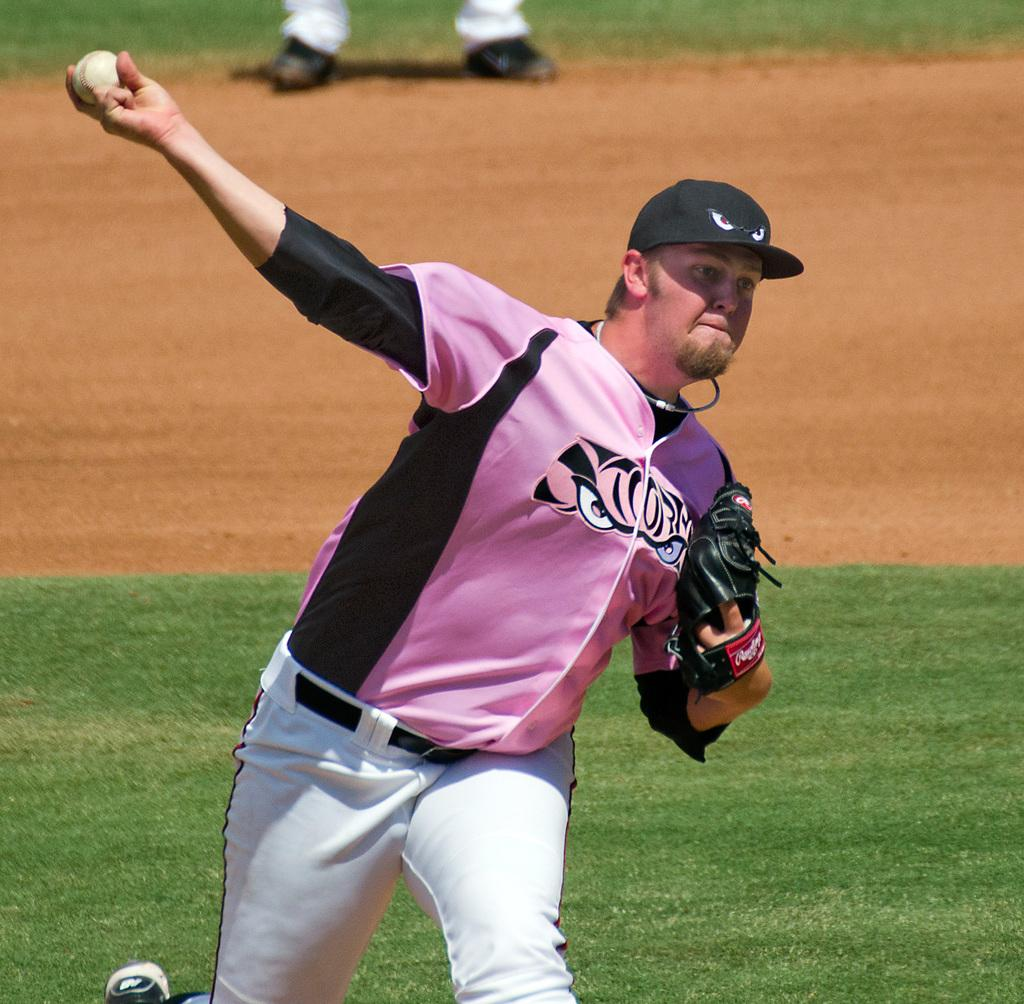Who is present in the image? There is a person in the image. What is the person wearing on their hand? The person is wearing a glove. What is the person holding in their hand? The person is holding a ball with their hand. What type of argument is the person having with their grandfather in the image? There is no grandfather or argument present in the image; it only features a person holding a ball while wearing a glove. 